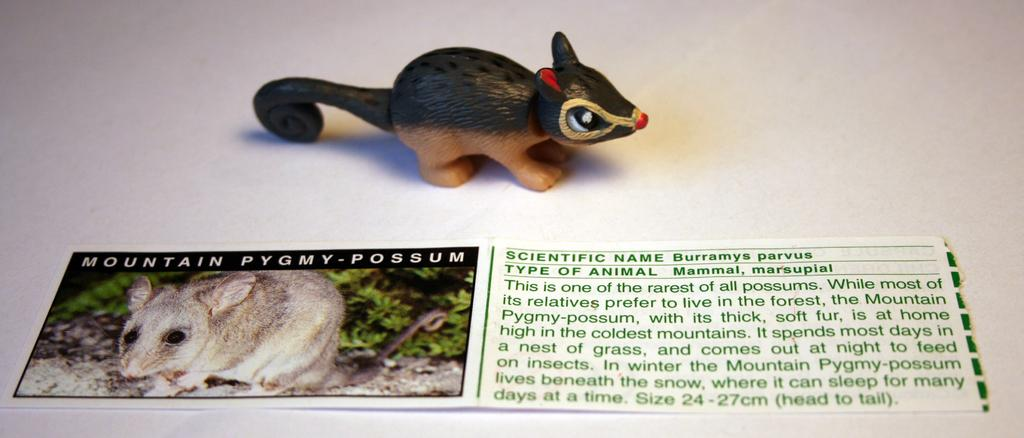What is featured in the image? There is a poster and a toy rat in the image. What can be read on the poster? There is writing on the poster. Where is the needle located in the image? There is no needle present in the image. What type of sea creature can be seen swimming near the toy rat in the image? There is no sea creature present in the image; it only features a poster and a toy rat. 